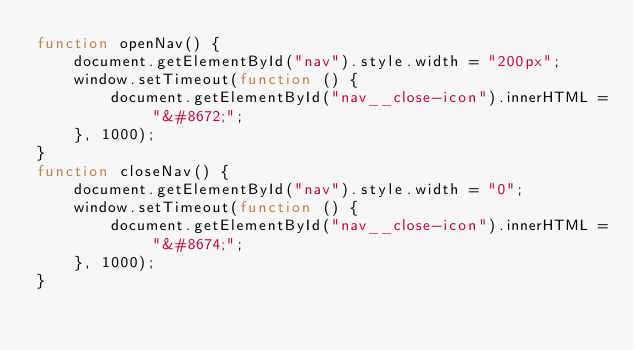<code> <loc_0><loc_0><loc_500><loc_500><_JavaScript_>function openNav() {
    document.getElementById("nav").style.width = "200px";
    window.setTimeout(function () {
        document.getElementById("nav__close-icon").innerHTML = "&#8672;";
    }, 1000);
}
function closeNav() {
    document.getElementById("nav").style.width = "0";
    window.setTimeout(function () {
        document.getElementById("nav__close-icon").innerHTML = "&#8674;";
    }, 1000);
}</code> 